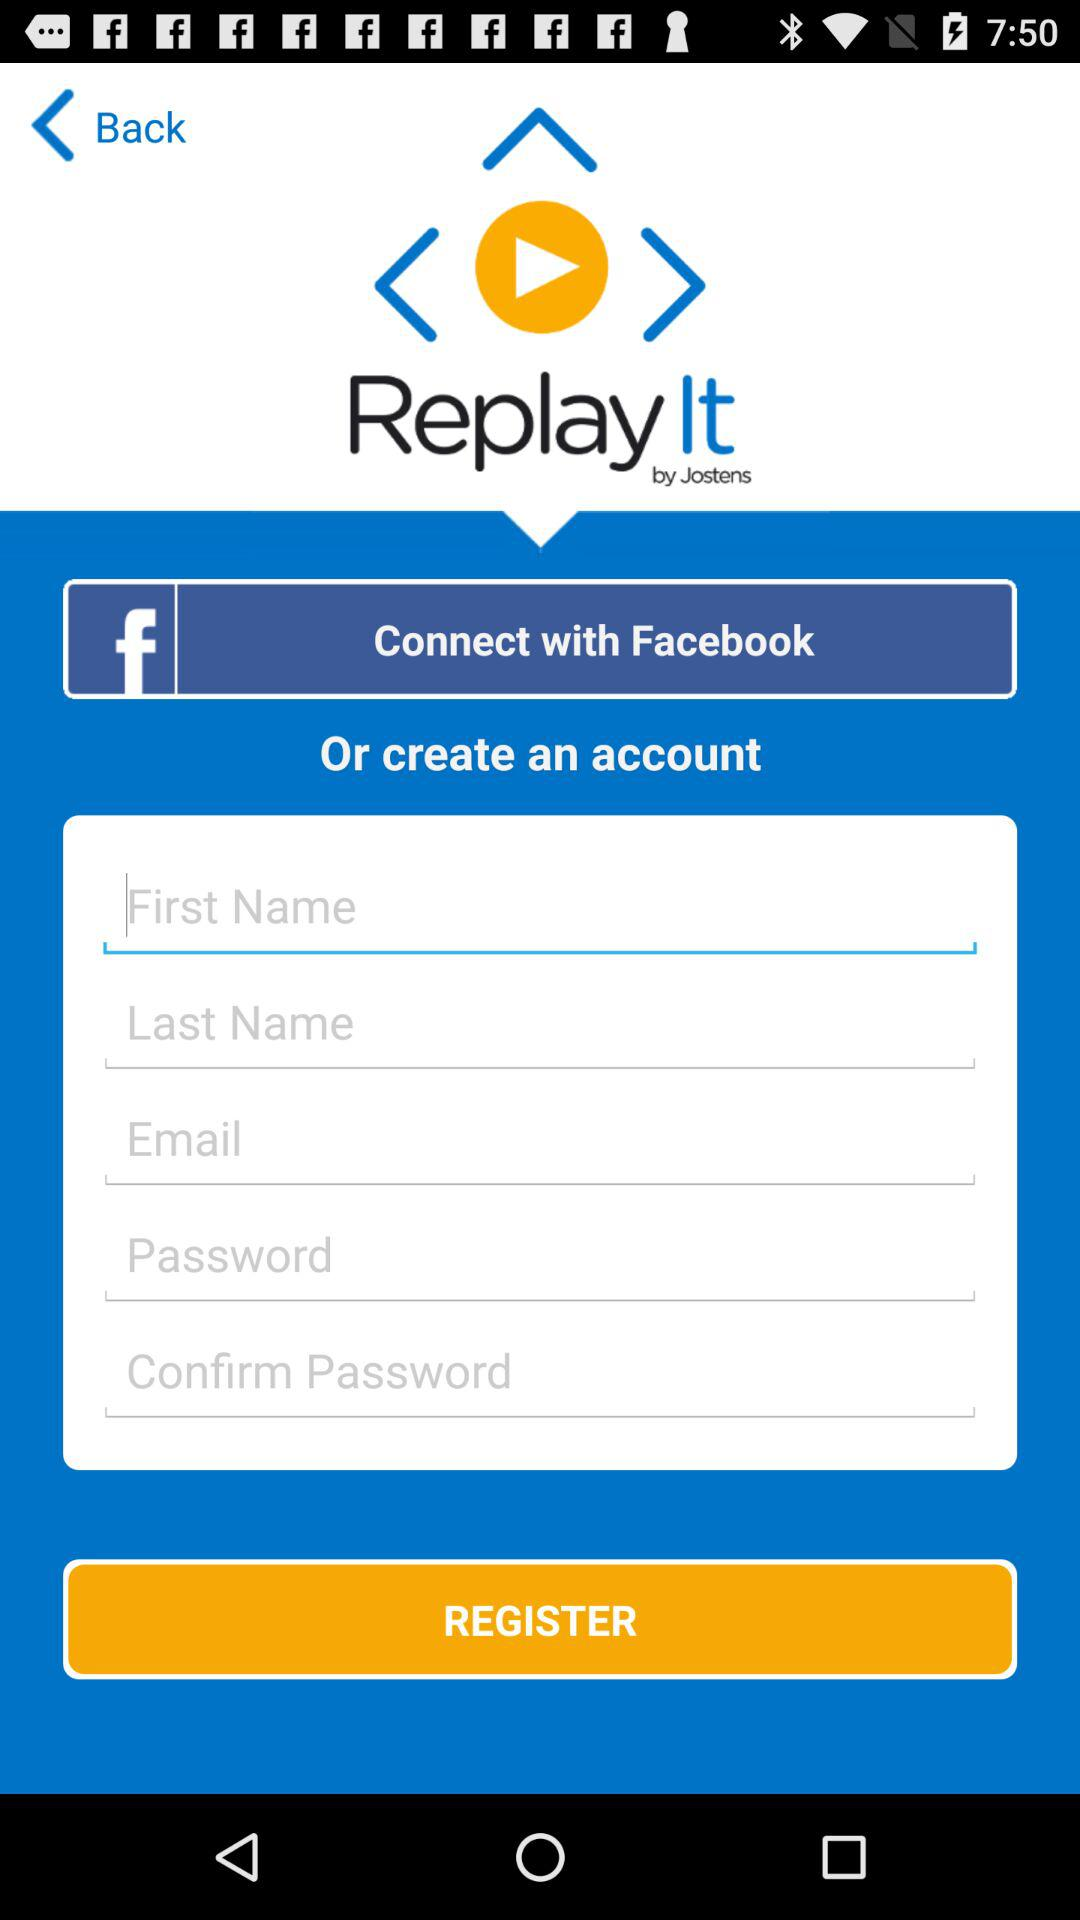What application can be used to connect? The application that can be used to connect is "Facebook". 